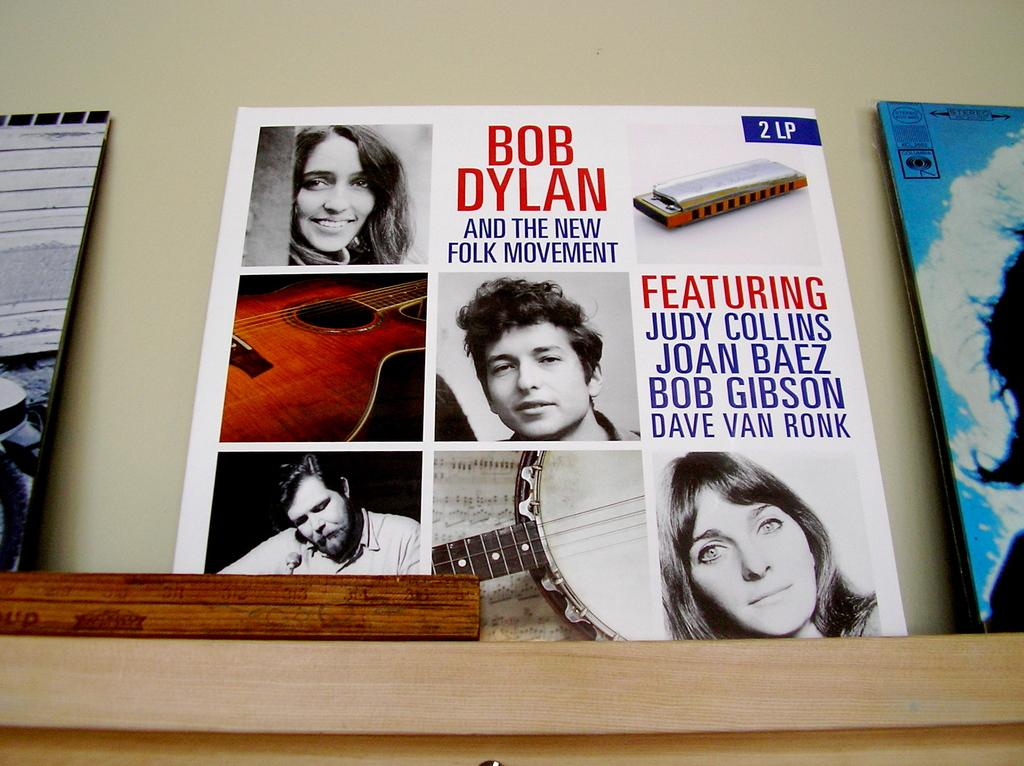<image>
Offer a succinct explanation of the picture presented. A Bob Dylan album also includes Joan Baez. 